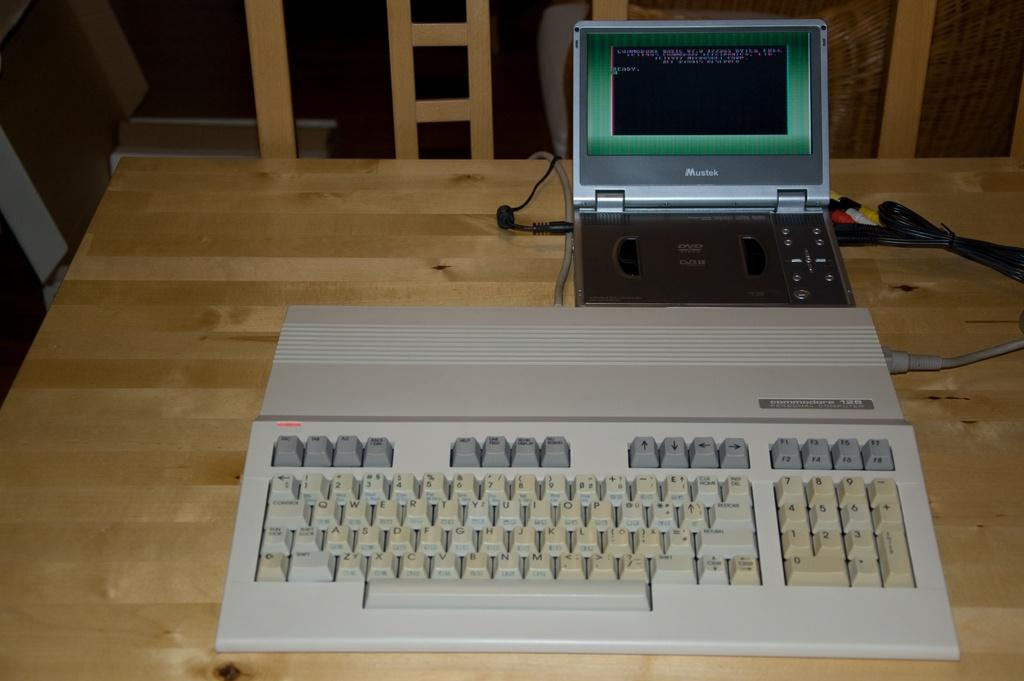<image>
Render a clear and concise summary of the photo. A Commodore 64 in front of a modern laptop. 